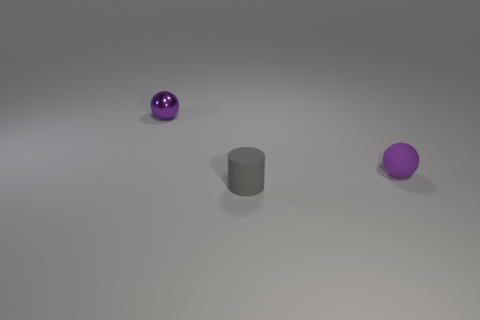How big is the purple sphere that is in front of the purple ball to the left of the purple sphere on the right side of the gray thing?
Keep it short and to the point. Small. There is another purple thing that is the same size as the metallic thing; what is it made of?
Your answer should be compact. Rubber. Is there another cylinder of the same size as the gray matte cylinder?
Keep it short and to the point. No. Does the ball in front of the shiny sphere have the same size as the tiny gray matte object?
Give a very brief answer. Yes. There is a tiny object that is to the right of the small metal thing and left of the purple rubber sphere; what shape is it?
Your answer should be compact. Cylinder. Is the number of tiny gray rubber objects that are behind the metal object greater than the number of large red objects?
Offer a terse response. No. What size is the ball that is the same material as the gray cylinder?
Your response must be concise. Small. How many metallic spheres have the same color as the shiny object?
Make the answer very short. 0. There is a ball in front of the small purple metal ball; is it the same color as the small matte cylinder?
Offer a very short reply. No. Are there an equal number of gray cylinders in front of the tiny gray matte object and shiny balls on the left side of the metal thing?
Your answer should be very brief. Yes. 